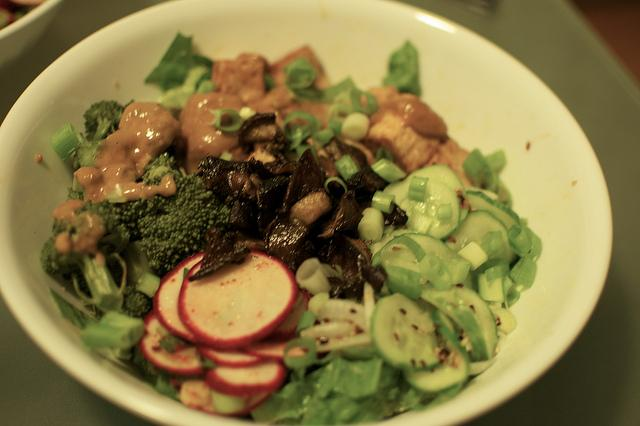What animal would most enjoy the food in the bowl?

Choices:
A) sheep
B) wolf
C) lion
D) hyena sheep 